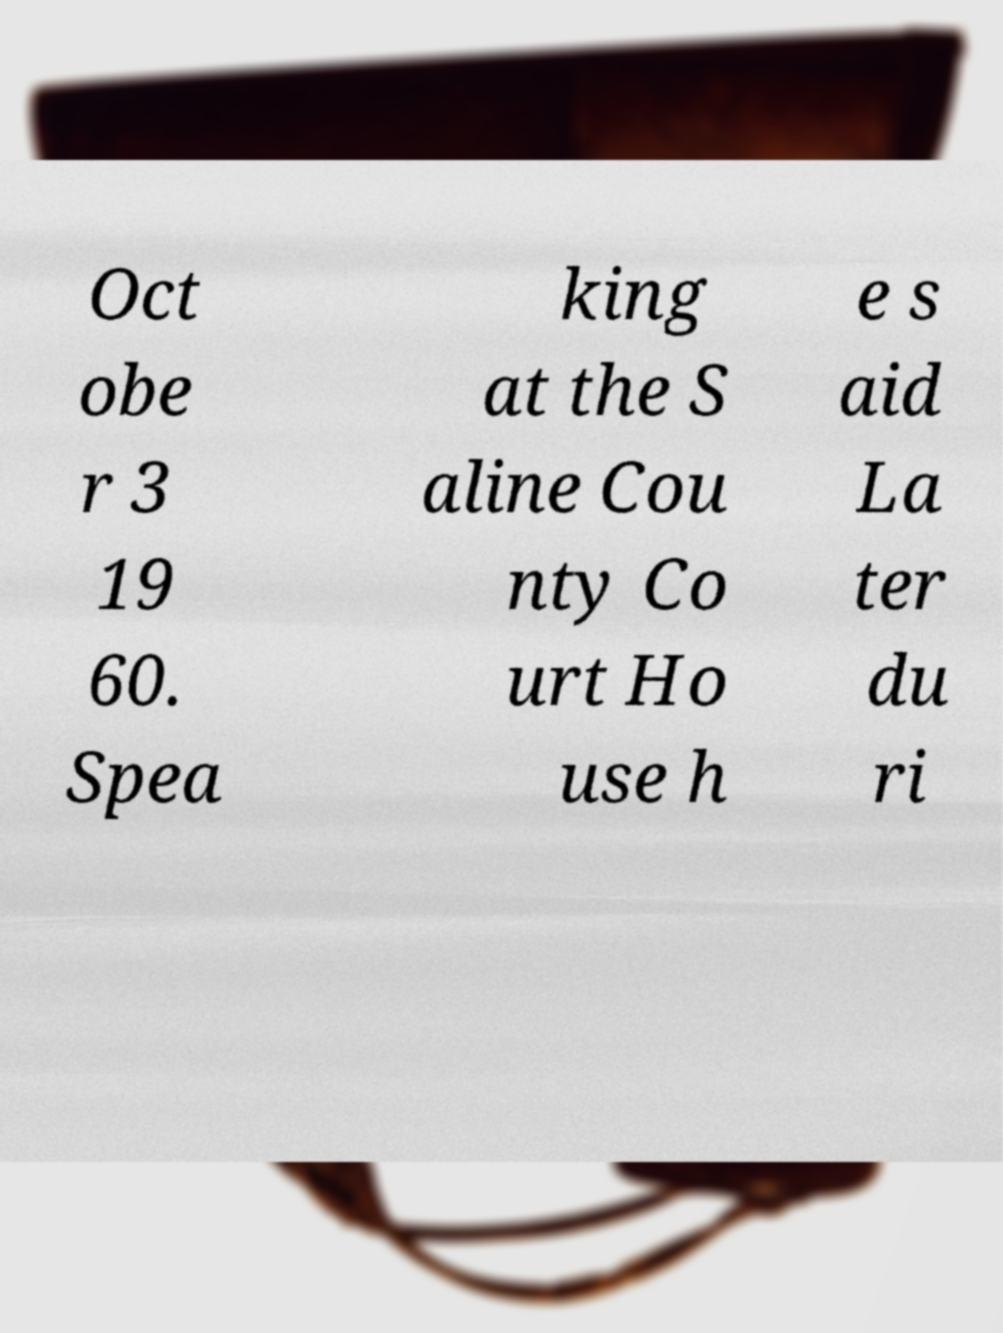Please read and relay the text visible in this image. What does it say? Oct obe r 3 19 60. Spea king at the S aline Cou nty Co urt Ho use h e s aid La ter du ri 